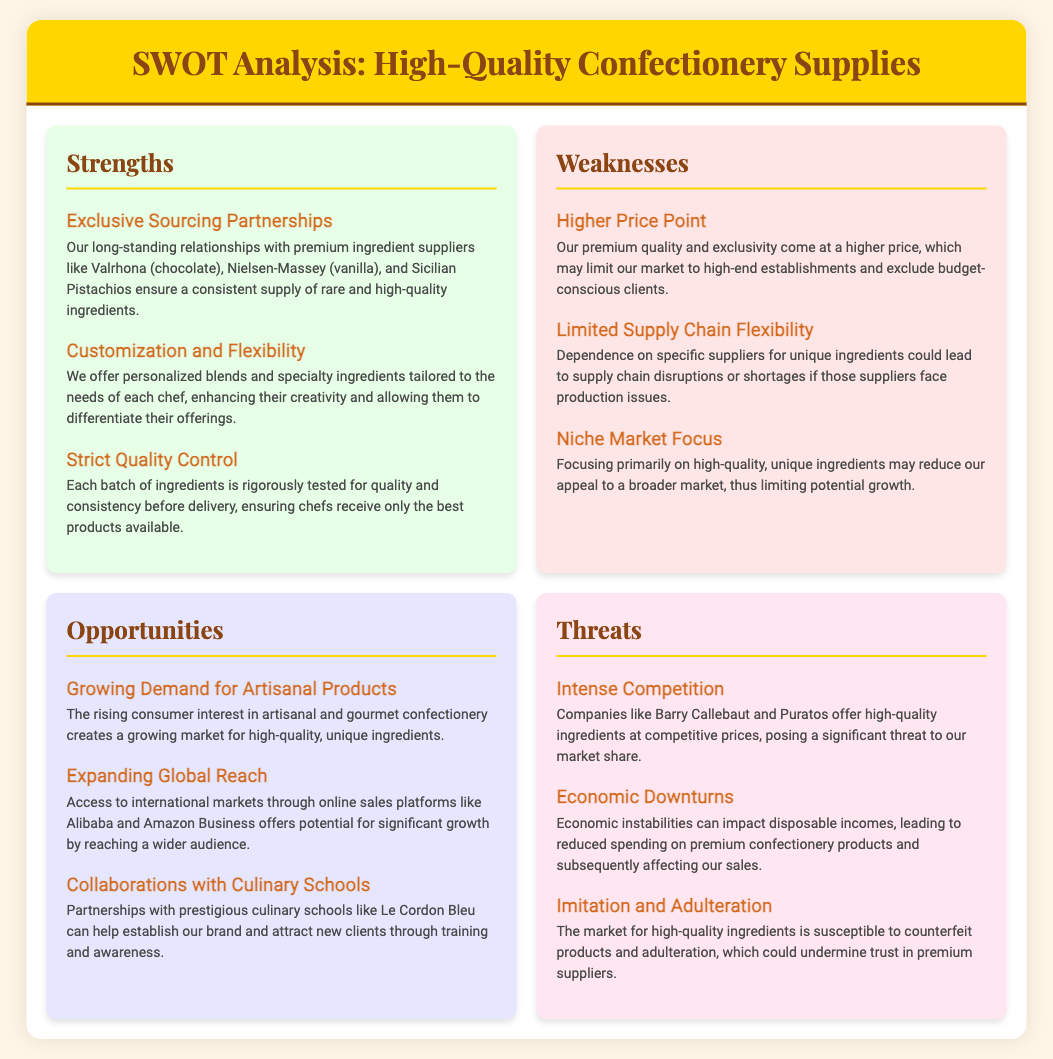what is one of the suppliers mentioned for ingredients? The document lists suppliers like Valrhona, Nielsen-Massey, and Sicilian Pistachios for high-quality ingredients.
Answer: Valrhona what is a key strength related to ingredient quality? The document states that each batch of ingredients is rigorously tested for consistency before delivery, ensuring the quality of products.
Answer: Strict Quality Control what is a major weakness regarding pricing? The document highlights that the premium quality and exclusivity can lead to a higher price point, which may limit the market.
Answer: Higher Price Point what opportunity is mentioned related to market trends? There is a growing demand for artisanal and gourmet products, which presents a market opportunity for unique ingredients.
Answer: Growing Demand for Artisanal Products who is a potential collaboration partner mentioned in the document? The document mentions partnerships with culinary schools, specifically naming Le Cordon Bleu as a prestigious institution for collaboration.
Answer: Le Cordon Bleu what is a significant threat to the market mentioned? The document outlines that intense competition from companies like Barry Callebaut and Puratos poses a threat to market share.
Answer: Intense Competition how does the document describe its focus on market segments? The document states that it has a niche market focus, which might limit overall appeal.
Answer: Niche Market Focus what financial impact could economic downturns have? The document explains that economic instabilities could result in reduced spending on premium confectionery products affecting sales.
Answer: Reduced spending on premium products 